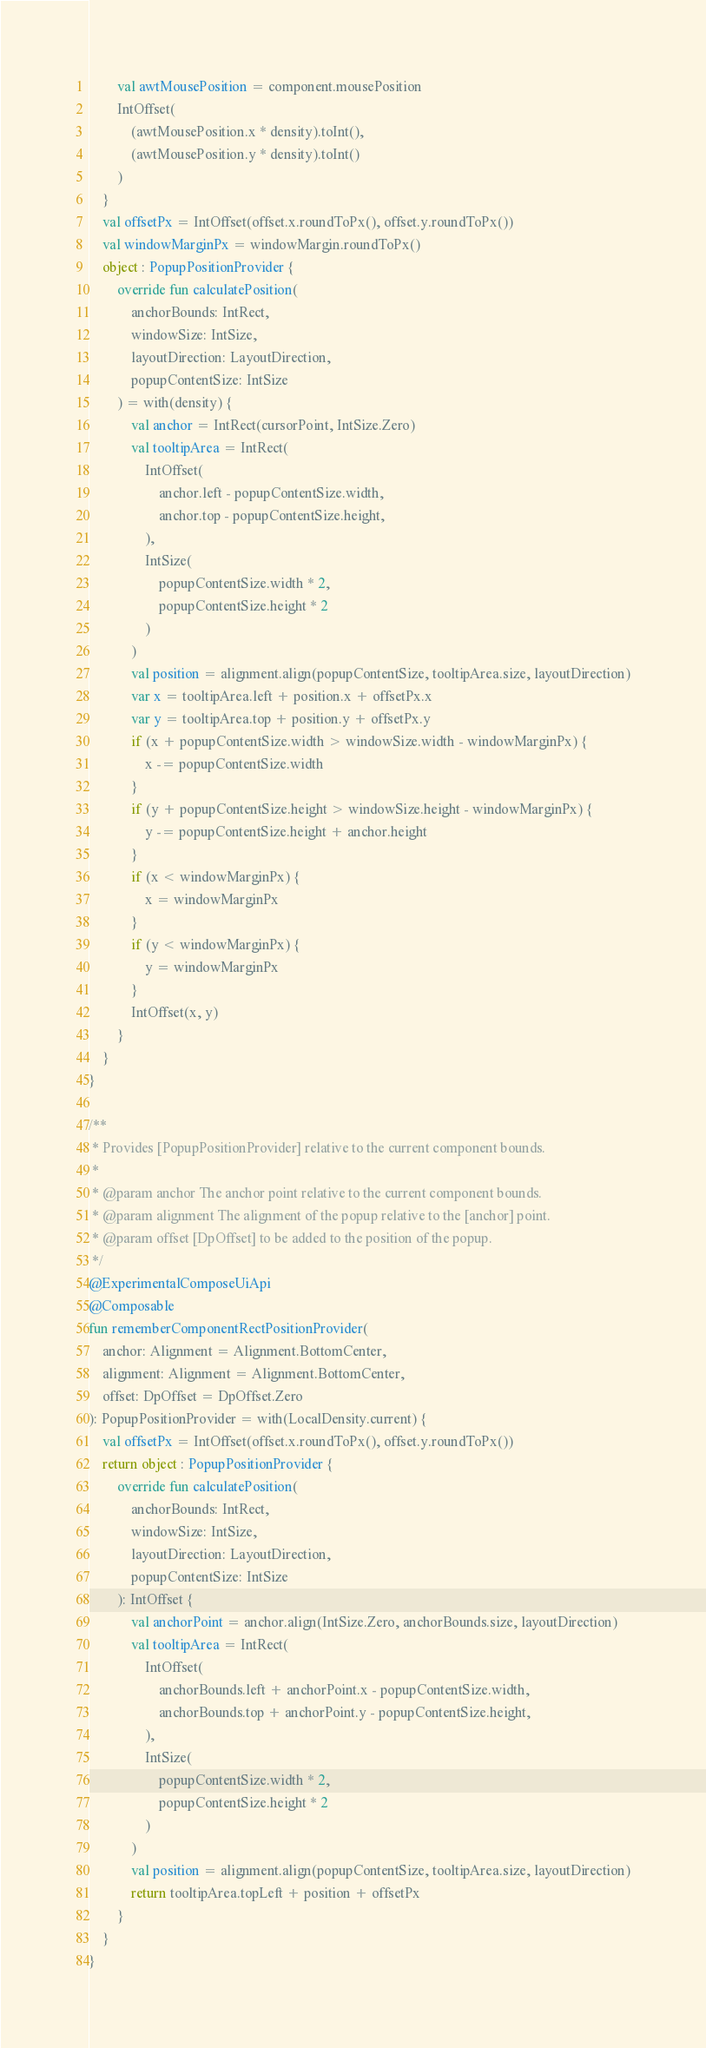Convert code to text. <code><loc_0><loc_0><loc_500><loc_500><_Kotlin_>        val awtMousePosition = component.mousePosition
        IntOffset(
            (awtMousePosition.x * density).toInt(),
            (awtMousePosition.y * density).toInt()
        )
    }
    val offsetPx = IntOffset(offset.x.roundToPx(), offset.y.roundToPx())
    val windowMarginPx = windowMargin.roundToPx()
    object : PopupPositionProvider {
        override fun calculatePosition(
            anchorBounds: IntRect,
            windowSize: IntSize,
            layoutDirection: LayoutDirection,
            popupContentSize: IntSize
        ) = with(density) {
            val anchor = IntRect(cursorPoint, IntSize.Zero)
            val tooltipArea = IntRect(
                IntOffset(
                    anchor.left - popupContentSize.width,
                    anchor.top - popupContentSize.height,
                ),
                IntSize(
                    popupContentSize.width * 2,
                    popupContentSize.height * 2
                )
            )
            val position = alignment.align(popupContentSize, tooltipArea.size, layoutDirection)
            var x = tooltipArea.left + position.x + offsetPx.x
            var y = tooltipArea.top + position.y + offsetPx.y
            if (x + popupContentSize.width > windowSize.width - windowMarginPx) {
                x -= popupContentSize.width
            }
            if (y + popupContentSize.height > windowSize.height - windowMarginPx) {
                y -= popupContentSize.height + anchor.height
            }
            if (x < windowMarginPx) {
                x = windowMarginPx
            }
            if (y < windowMarginPx) {
                y = windowMarginPx
            }
            IntOffset(x, y)
        }
    }
}

/**
 * Provides [PopupPositionProvider] relative to the current component bounds.
 *
 * @param anchor The anchor point relative to the current component bounds.
 * @param alignment The alignment of the popup relative to the [anchor] point.
 * @param offset [DpOffset] to be added to the position of the popup.
 */
@ExperimentalComposeUiApi
@Composable
fun rememberComponentRectPositionProvider(
    anchor: Alignment = Alignment.BottomCenter,
    alignment: Alignment = Alignment.BottomCenter,
    offset: DpOffset = DpOffset.Zero
): PopupPositionProvider = with(LocalDensity.current) {
    val offsetPx = IntOffset(offset.x.roundToPx(), offset.y.roundToPx())
    return object : PopupPositionProvider {
        override fun calculatePosition(
            anchorBounds: IntRect,
            windowSize: IntSize,
            layoutDirection: LayoutDirection,
            popupContentSize: IntSize
        ): IntOffset {
            val anchorPoint = anchor.align(IntSize.Zero, anchorBounds.size, layoutDirection)
            val tooltipArea = IntRect(
                IntOffset(
                    anchorBounds.left + anchorPoint.x - popupContentSize.width,
                    anchorBounds.top + anchorPoint.y - popupContentSize.height,
                ),
                IntSize(
                    popupContentSize.width * 2,
                    popupContentSize.height * 2
                )
            )
            val position = alignment.align(popupContentSize, tooltipArea.size, layoutDirection)
            return tooltipArea.topLeft + position + offsetPx
        }
    }
}
</code> 